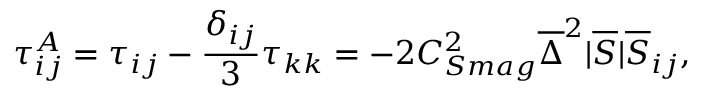<formula> <loc_0><loc_0><loc_500><loc_500>\tau _ { i j } ^ { A } = \tau _ { i j } - \frac { \delta _ { i j } } { 3 } \tau _ { k k } = - 2 C _ { S m a g } ^ { 2 } \overline { \Delta } ^ { 2 } | \overline { S } | \overline { S } _ { i j } ,</formula> 